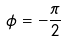Convert formula to latex. <formula><loc_0><loc_0><loc_500><loc_500>\phi = - \frac { \pi } { 2 }</formula> 